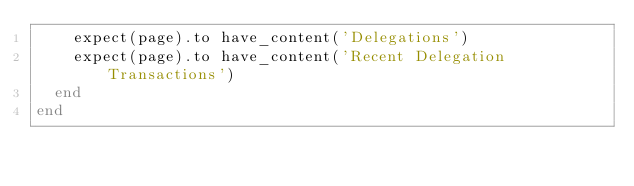<code> <loc_0><loc_0><loc_500><loc_500><_Ruby_>    expect(page).to have_content('Delegations')
    expect(page).to have_content('Recent Delegation Transactions')
  end
end
</code> 